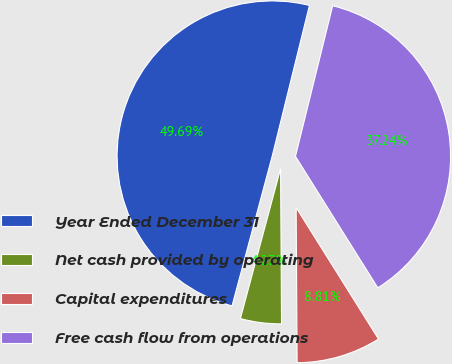Convert chart to OTSL. <chart><loc_0><loc_0><loc_500><loc_500><pie_chart><fcel>Year Ended December 31<fcel>Net cash provided by operating<fcel>Capital expenditures<fcel>Free cash flow from operations<nl><fcel>49.69%<fcel>4.27%<fcel>8.81%<fcel>37.24%<nl></chart> 